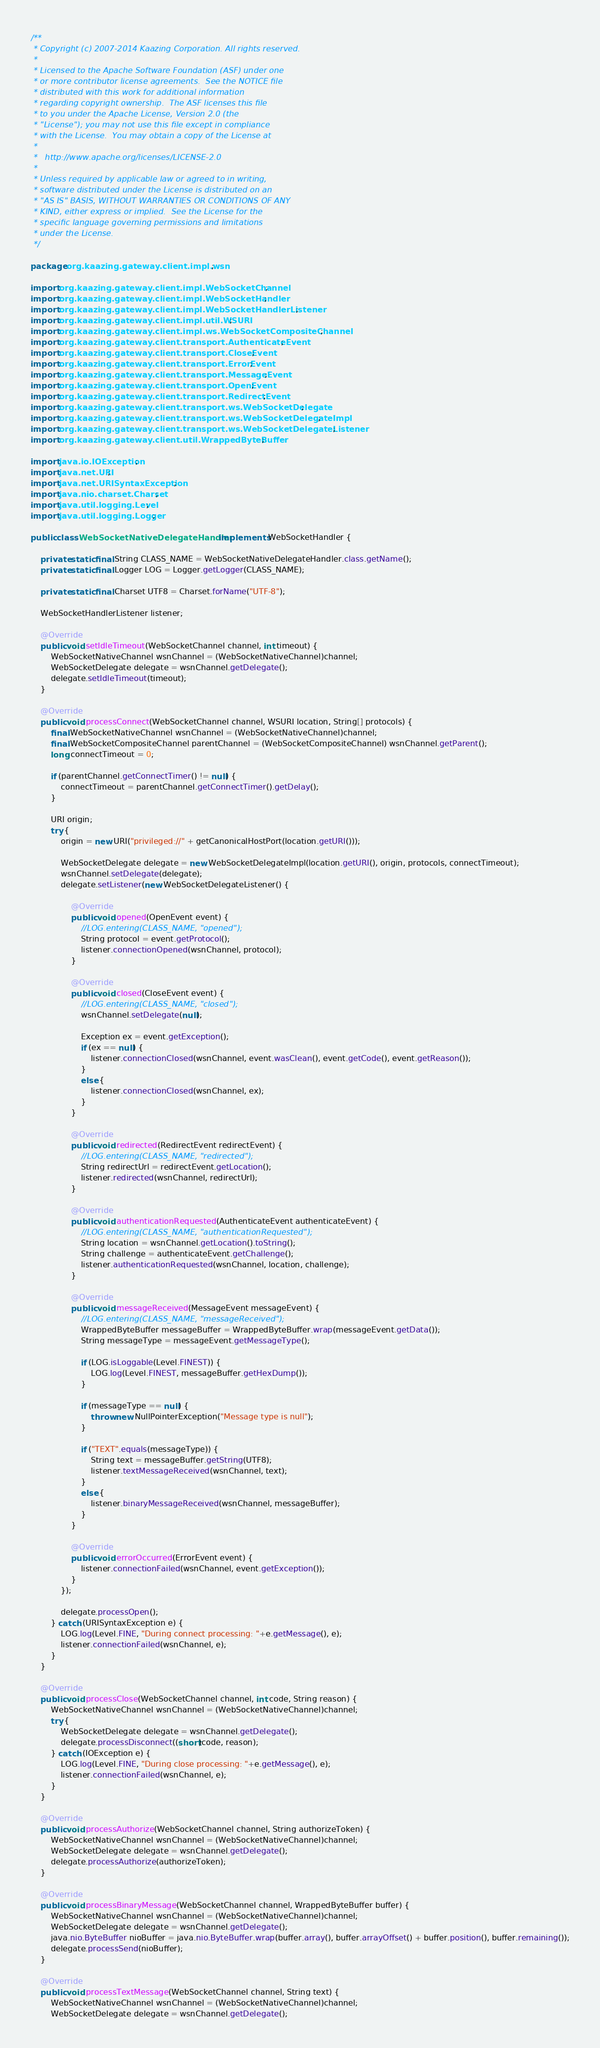<code> <loc_0><loc_0><loc_500><loc_500><_Java_>/**
 * Copyright (c) 2007-2014 Kaazing Corporation. All rights reserved.
 * 
 * Licensed to the Apache Software Foundation (ASF) under one
 * or more contributor license agreements.  See the NOTICE file
 * distributed with this work for additional information
 * regarding copyright ownership.  The ASF licenses this file
 * to you under the Apache License, Version 2.0 (the
 * "License"); you may not use this file except in compliance
 * with the License.  You may obtain a copy of the License at
 * 
 *   http://www.apache.org/licenses/LICENSE-2.0
 * 
 * Unless required by applicable law or agreed to in writing,
 * software distributed under the License is distributed on an
 * "AS IS" BASIS, WITHOUT WARRANTIES OR CONDITIONS OF ANY
 * KIND, either express or implied.  See the License for the
 * specific language governing permissions and limitations
 * under the License.
 */

package org.kaazing.gateway.client.impl.wsn;

import org.kaazing.gateway.client.impl.WebSocketChannel;
import org.kaazing.gateway.client.impl.WebSocketHandler;
import org.kaazing.gateway.client.impl.WebSocketHandlerListener;
import org.kaazing.gateway.client.impl.util.WSURI;
import org.kaazing.gateway.client.impl.ws.WebSocketCompositeChannel;
import org.kaazing.gateway.client.transport.AuthenticateEvent;
import org.kaazing.gateway.client.transport.CloseEvent;
import org.kaazing.gateway.client.transport.ErrorEvent;
import org.kaazing.gateway.client.transport.MessageEvent;
import org.kaazing.gateway.client.transport.OpenEvent;
import org.kaazing.gateway.client.transport.RedirectEvent;
import org.kaazing.gateway.client.transport.ws.WebSocketDelegate;
import org.kaazing.gateway.client.transport.ws.WebSocketDelegateImpl;
import org.kaazing.gateway.client.transport.ws.WebSocketDelegateListener;
import org.kaazing.gateway.client.util.WrappedByteBuffer;

import java.io.IOException;
import java.net.URI;
import java.net.URISyntaxException;
import java.nio.charset.Charset;
import java.util.logging.Level;
import java.util.logging.Logger;

public class WebSocketNativeDelegateHandler implements WebSocketHandler {

    private static final String CLASS_NAME = WebSocketNativeDelegateHandler.class.getName();
    private static final Logger LOG = Logger.getLogger(CLASS_NAME);

    private static final Charset UTF8 = Charset.forName("UTF-8");

    WebSocketHandlerListener listener;
    
    @Override
    public void setIdleTimeout(WebSocketChannel channel, int timeout) {
        WebSocketNativeChannel wsnChannel = (WebSocketNativeChannel)channel;
        WebSocketDelegate delegate = wsnChannel.getDelegate();
        delegate.setIdleTimeout(timeout);
    }
    
    @Override
    public void processConnect(WebSocketChannel channel, WSURI location, String[] protocols) {
        final WebSocketNativeChannel wsnChannel = (WebSocketNativeChannel)channel;
        final WebSocketCompositeChannel parentChannel = (WebSocketCompositeChannel) wsnChannel.getParent();
        long connectTimeout = 0;
        
        if (parentChannel.getConnectTimer() != null) {
            connectTimeout = parentChannel.getConnectTimer().getDelay();
        }

        URI origin;
        try {
            origin = new URI("privileged://" + getCanonicalHostPort(location.getURI()));
        
            WebSocketDelegate delegate = new WebSocketDelegateImpl(location.getURI(), origin, protocols, connectTimeout);
            wsnChannel.setDelegate(delegate);
            delegate.setListener(new WebSocketDelegateListener() {
                
                @Override
                public void opened(OpenEvent event) {
                    //LOG.entering(CLASS_NAME, "opened");
                    String protocol = event.getProtocol();
                    listener.connectionOpened(wsnChannel, protocol);
                }
                
                @Override
                public void closed(CloseEvent event) {
                    //LOG.entering(CLASS_NAME, "closed");
                    wsnChannel.setDelegate(null);
                    
                    Exception ex = event.getException();
                    if (ex == null) {
                        listener.connectionClosed(wsnChannel, event.wasClean(), event.getCode(), event.getReason());
                    }
                    else {
                        listener.connectionClosed(wsnChannel, ex);
                    }
                }

                @Override
                public void redirected(RedirectEvent redirectEvent) {
                    //LOG.entering(CLASS_NAME, "redirected");
                    String redirectUrl = redirectEvent.getLocation();
                    listener.redirected(wsnChannel, redirectUrl);
                }
                
                @Override
                public void authenticationRequested(AuthenticateEvent authenticateEvent) {
                    //LOG.entering(CLASS_NAME, "authenticationRequested");
                    String location = wsnChannel.getLocation().toString();
                    String challenge = authenticateEvent.getChallenge();
                    listener.authenticationRequested(wsnChannel, location, challenge);
                }
                
                @Override
                public void messageReceived(MessageEvent messageEvent) {
                    //LOG.entering(CLASS_NAME, "messageReceived");
                    WrappedByteBuffer messageBuffer = WrappedByteBuffer.wrap(messageEvent.getData());
                    String messageType = messageEvent.getMessageType();
                    
                    if (LOG.isLoggable(Level.FINEST)) {
                        LOG.log(Level.FINEST, messageBuffer.getHexDump());
                    }
                    
                    if (messageType == null) {
                        throw new NullPointerException("Message type is null");
                    }
                    
                    if ("TEXT".equals(messageType)) {
                        String text = messageBuffer.getString(UTF8);
                        listener.textMessageReceived(wsnChannel, text);
                    }
                    else {
                        listener.binaryMessageReceived(wsnChannel, messageBuffer);
                    }
                }
                
                @Override
                public void errorOccurred(ErrorEvent event) {
                    listener.connectionFailed(wsnChannel, event.getException());
                }
            });
                        
            delegate.processOpen();
        } catch (URISyntaxException e) {
            LOG.log(Level.FINE, "During connect processing: "+e.getMessage(), e);
            listener.connectionFailed(wsnChannel, e);
        }
    }

    @Override
    public void processClose(WebSocketChannel channel, int code, String reason) {
        WebSocketNativeChannel wsnChannel = (WebSocketNativeChannel)channel;
        try {
            WebSocketDelegate delegate = wsnChannel.getDelegate();
            delegate.processDisconnect((short)code, reason);
        } catch (IOException e) {
            LOG.log(Level.FINE, "During close processing: "+e.getMessage(), e);
            listener.connectionFailed(wsnChannel, e);
        }
    }

    @Override
    public void processAuthorize(WebSocketChannel channel, String authorizeToken) {
        WebSocketNativeChannel wsnChannel = (WebSocketNativeChannel)channel;
        WebSocketDelegate delegate = wsnChannel.getDelegate();
        delegate.processAuthorize(authorizeToken);
    }

    @Override
    public void processBinaryMessage(WebSocketChannel channel, WrappedByteBuffer buffer) {
        WebSocketNativeChannel wsnChannel = (WebSocketNativeChannel)channel;
        WebSocketDelegate delegate = wsnChannel.getDelegate();
        java.nio.ByteBuffer nioBuffer = java.nio.ByteBuffer.wrap(buffer.array(), buffer.arrayOffset() + buffer.position(), buffer.remaining());
        delegate.processSend(nioBuffer);
    }

    @Override
    public void processTextMessage(WebSocketChannel channel, String text) {
        WebSocketNativeChannel wsnChannel = (WebSocketNativeChannel)channel;
        WebSocketDelegate delegate = wsnChannel.getDelegate();</code> 